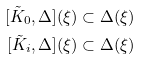<formula> <loc_0><loc_0><loc_500><loc_500>[ \tilde { K } _ { 0 } , \Delta ] ( \xi ) \subset \Delta ( \xi ) \\ [ \tilde { K } _ { i } , \Delta ] ( \xi ) \subset \Delta ( \xi )</formula> 